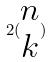Convert formula to latex. <formula><loc_0><loc_0><loc_500><loc_500>2 ( \begin{matrix} n \\ k \end{matrix} )</formula> 